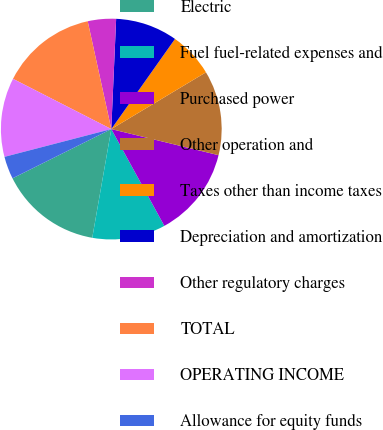Convert chart. <chart><loc_0><loc_0><loc_500><loc_500><pie_chart><fcel>Electric<fcel>Fuel fuel-related expenses and<fcel>Purchased power<fcel>Other operation and<fcel>Taxes other than income taxes<fcel>Depreciation and amortization<fcel>Other regulatory charges<fcel>TOTAL<fcel>OPERATING INCOME<fcel>Allowance for equity funds<nl><fcel>14.88%<fcel>10.74%<fcel>13.22%<fcel>12.4%<fcel>6.61%<fcel>9.09%<fcel>4.13%<fcel>14.05%<fcel>11.57%<fcel>3.31%<nl></chart> 